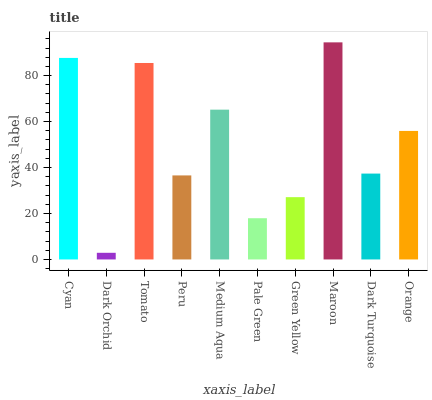Is Dark Orchid the minimum?
Answer yes or no. Yes. Is Maroon the maximum?
Answer yes or no. Yes. Is Tomato the minimum?
Answer yes or no. No. Is Tomato the maximum?
Answer yes or no. No. Is Tomato greater than Dark Orchid?
Answer yes or no. Yes. Is Dark Orchid less than Tomato?
Answer yes or no. Yes. Is Dark Orchid greater than Tomato?
Answer yes or no. No. Is Tomato less than Dark Orchid?
Answer yes or no. No. Is Orange the high median?
Answer yes or no. Yes. Is Dark Turquoise the low median?
Answer yes or no. Yes. Is Cyan the high median?
Answer yes or no. No. Is Maroon the low median?
Answer yes or no. No. 